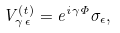<formula> <loc_0><loc_0><loc_500><loc_500>V _ { \gamma \, \epsilon } ^ { ( t ) } = e ^ { i \gamma \Phi } \sigma _ { \epsilon } ,</formula> 